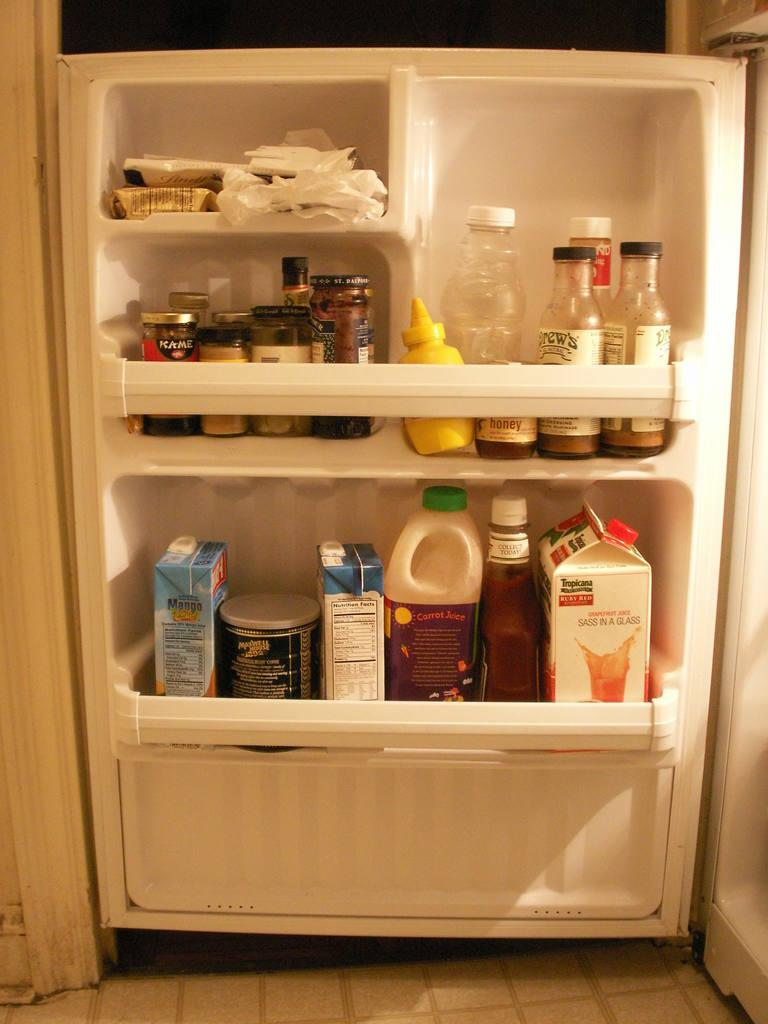<image>
Present a compact description of the photo's key features. Open refrigerator with some orange juice that says TROPICANA on it. 